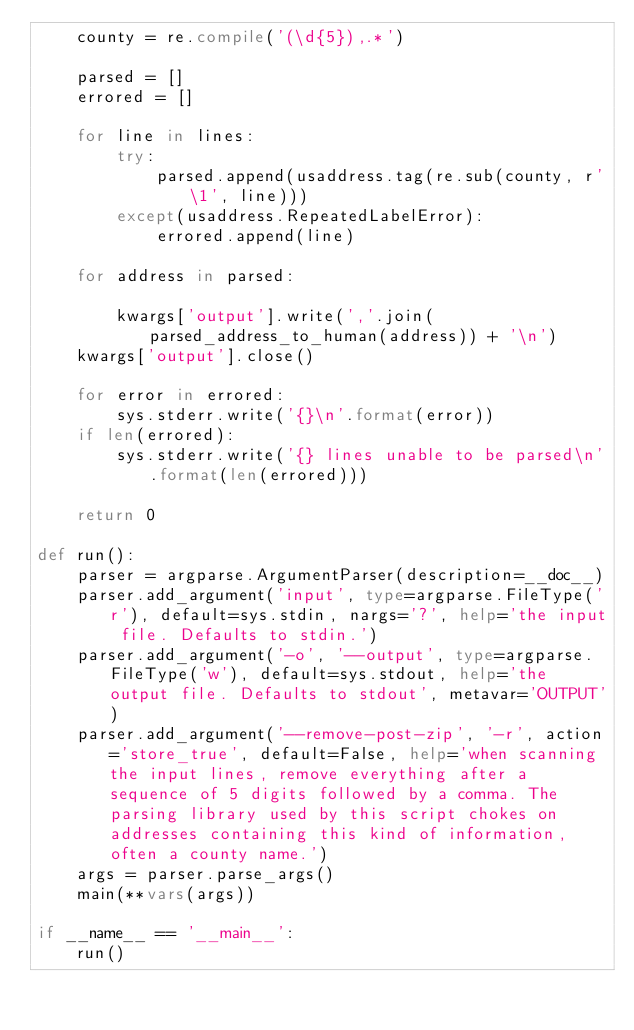<code> <loc_0><loc_0><loc_500><loc_500><_Python_>    county = re.compile('(\d{5}),.*')
    
    parsed = []
    errored = []
    
    for line in lines:
        try:
            parsed.append(usaddress.tag(re.sub(county, r'\1', line)))
        except(usaddress.RepeatedLabelError):
            errored.append(line)
            
    for address in parsed:
        
        kwargs['output'].write(','.join(parsed_address_to_human(address)) + '\n')
    kwargs['output'].close()
    
    for error in errored:
        sys.stderr.write('{}\n'.format(error))
    if len(errored):
        sys.stderr.write('{} lines unable to be parsed\n'.format(len(errored)))
    
    return 0

def run():
    parser = argparse.ArgumentParser(description=__doc__)
    parser.add_argument('input', type=argparse.FileType('r'), default=sys.stdin, nargs='?', help='the input file. Defaults to stdin.')
    parser.add_argument('-o', '--output', type=argparse.FileType('w'), default=sys.stdout, help='the output file. Defaults to stdout', metavar='OUTPUT')
    parser.add_argument('--remove-post-zip', '-r', action='store_true', default=False, help='when scanning the input lines, remove everything after a sequence of 5 digits followed by a comma. The parsing library used by this script chokes on addresses containing this kind of information, often a county name.')
    args = parser.parse_args()
    main(**vars(args))

if __name__ == '__main__':
    run()
</code> 